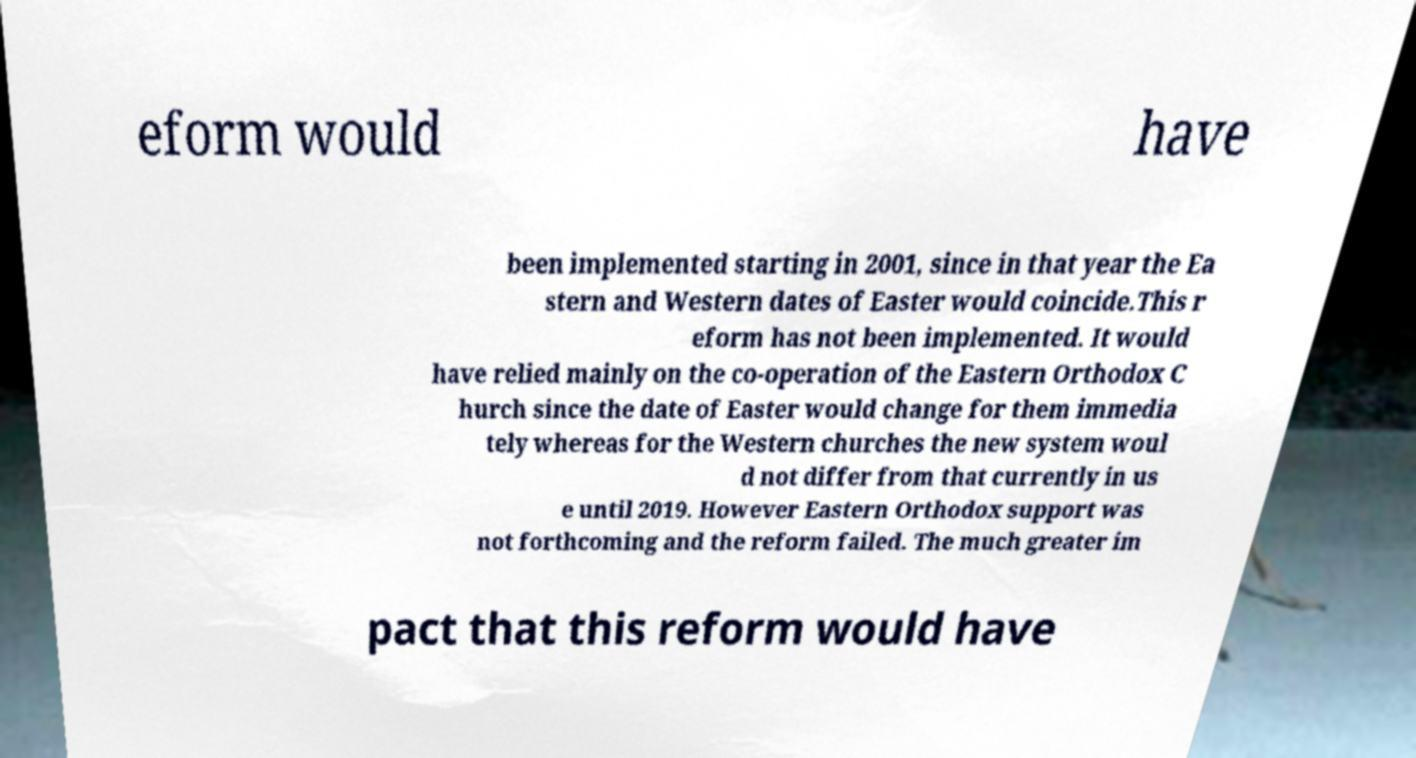Please read and relay the text visible in this image. What does it say? eform would have been implemented starting in 2001, since in that year the Ea stern and Western dates of Easter would coincide.This r eform has not been implemented. It would have relied mainly on the co-operation of the Eastern Orthodox C hurch since the date of Easter would change for them immedia tely whereas for the Western churches the new system woul d not differ from that currently in us e until 2019. However Eastern Orthodox support was not forthcoming and the reform failed. The much greater im pact that this reform would have 